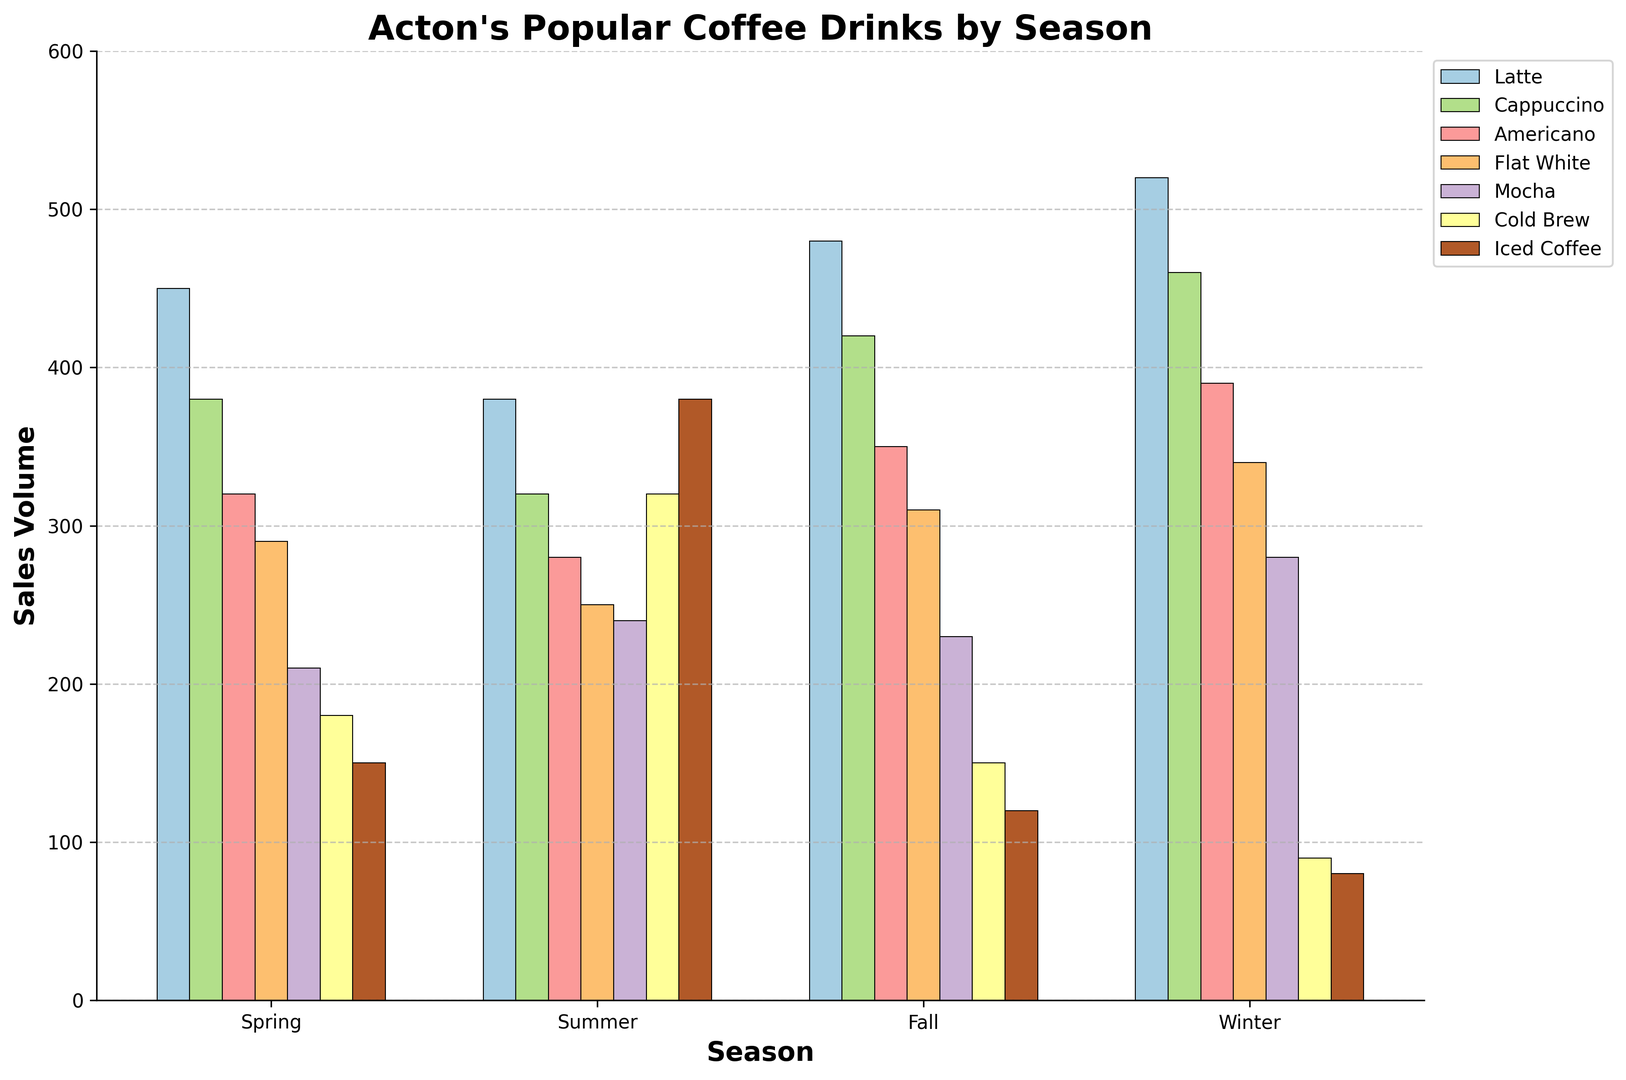Which season has the highest sales volume for Lattes? To find the season with the highest sales volume for Lattes, look at the height of the bars labeled "Latte" across all seasons. The bar for Winter is the highest, indicating the highest sales volume.
Answer: Winter Which drink has the lowest overall sales volume in Winter? Look at all the bars labeled under Winter and compare their heights. The shortest bar, representing the drink with the lowest sales, is Iced Coffee.
Answer: Iced Coffee What is the total sales volume for Cold Brew across all seasons? Add up the sales volumes for Cold Brew in each season: Spring (180), Summer (320), Fall (150), and Winter (90). The total sum is 180 + 320 + 150 + 90 = 740.
Answer: 740 Compare the sales volume of Cappuccinos in Fall and Lattes in Summer. Which one is higher? Look at the heights of the Cappuccino bar in Fall and the Latte bar in Summer. The bar for Cappuccino in Fall (420) is higher than the bar for Latte in Summer (380).
Answer: Cappuccinos in Fall By what percentage did Latte sales increase from Summer to Fall? First, calculate the difference in sales volumes: 480 (Fall) - 380 (Summer) = 100. Then, divide by the Summer volume and multiply by 100 to get the percentage: (100 / 380) * 100 = 26.32%.
Answer: 26.32% How do the sales of Flat White change from Spring to Winter? Compare the Flat White bars for Spring (290) and Winter (340). The sales increase from 290 in Spring to 340 in Winter. The change in sales volume is 340 - 290 = 50.
Answer: Increase by 50 What is the average sales volume of Americanos across all seasons? Sum the sales volumes for Americanos: Spring (320), Summer (280), Fall (350), Winter (390). The sum is 320 + 280 + 350 + 390 = 1340. Divide this by the number of seasons (4) to get the average: 1340 / 4 = 335.
Answer: 335 